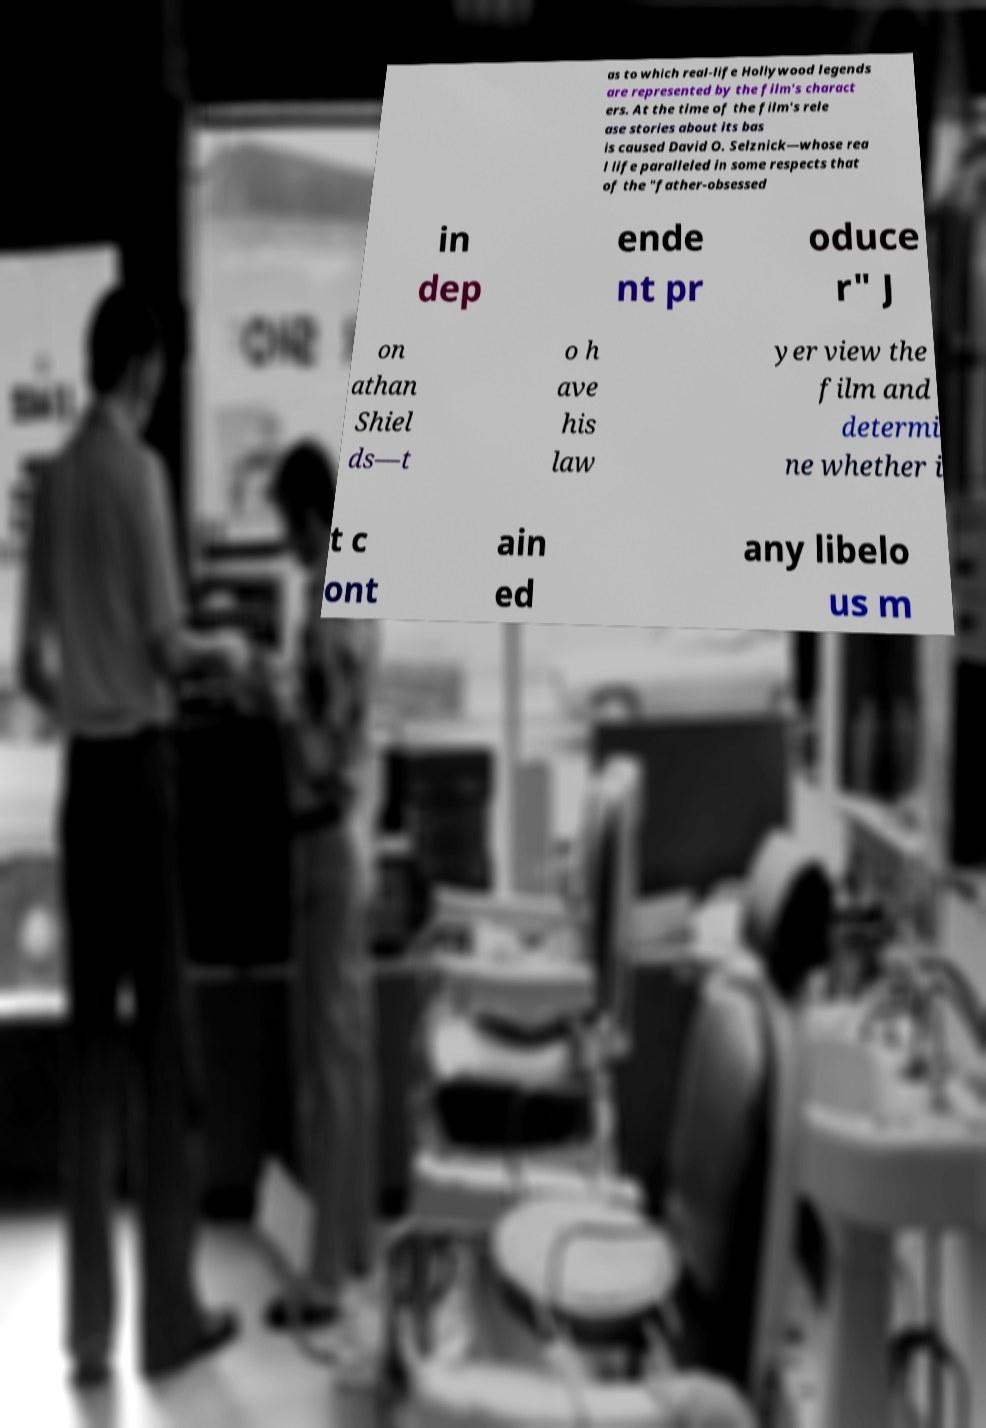Could you assist in decoding the text presented in this image and type it out clearly? as to which real-life Hollywood legends are represented by the film's charact ers. At the time of the film's rele ase stories about its bas is caused David O. Selznick—whose rea l life paralleled in some respects that of the "father-obsessed in dep ende nt pr oduce r" J on athan Shiel ds—t o h ave his law yer view the film and determi ne whether i t c ont ain ed any libelo us m 